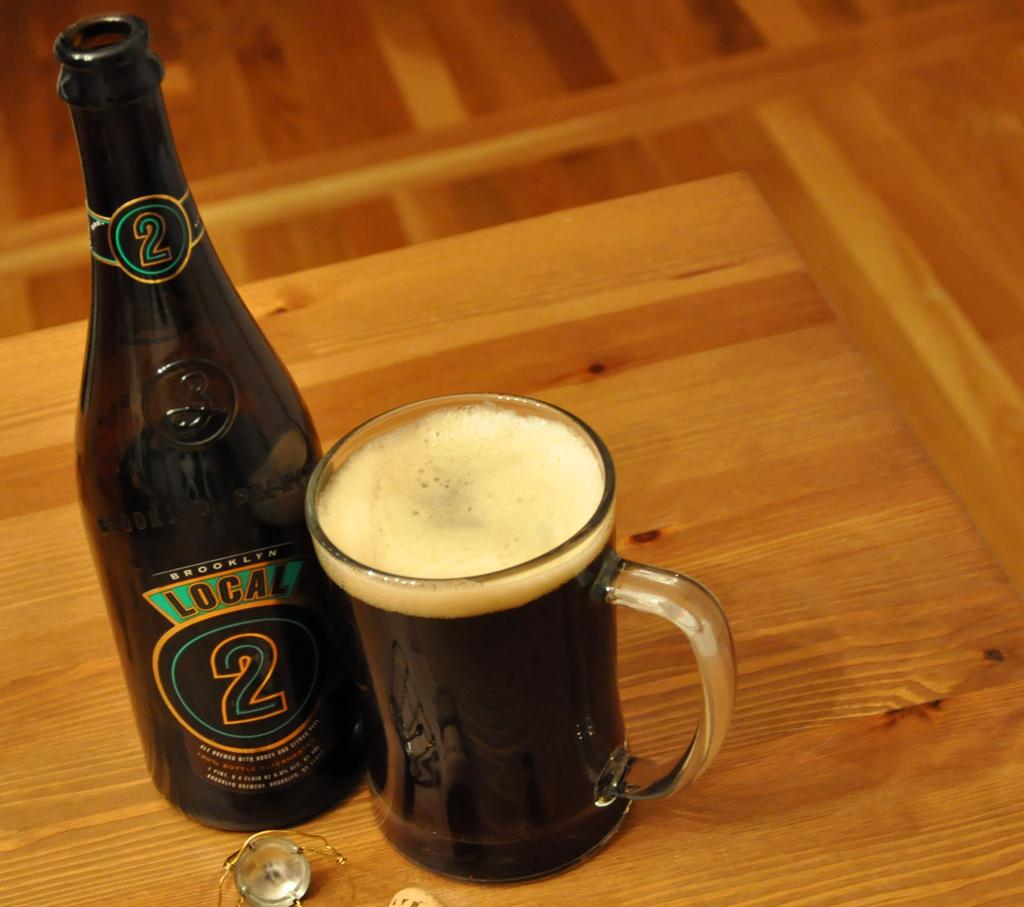Provide a one-sentence caption for the provided image. a bottle of beer with the label reading brooklyn local 2. 